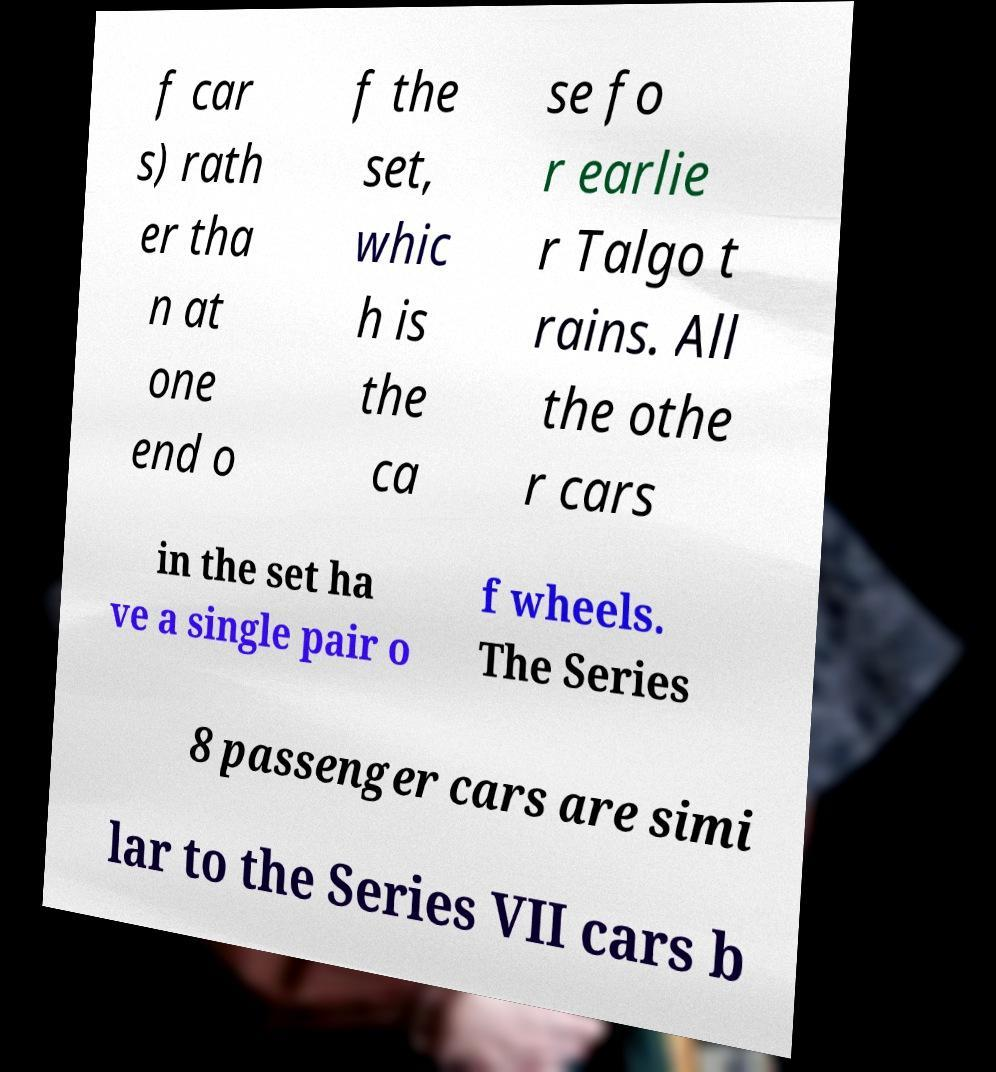For documentation purposes, I need the text within this image transcribed. Could you provide that? f car s) rath er tha n at one end o f the set, whic h is the ca se fo r earlie r Talgo t rains. All the othe r cars in the set ha ve a single pair o f wheels. The Series 8 passenger cars are simi lar to the Series VII cars b 